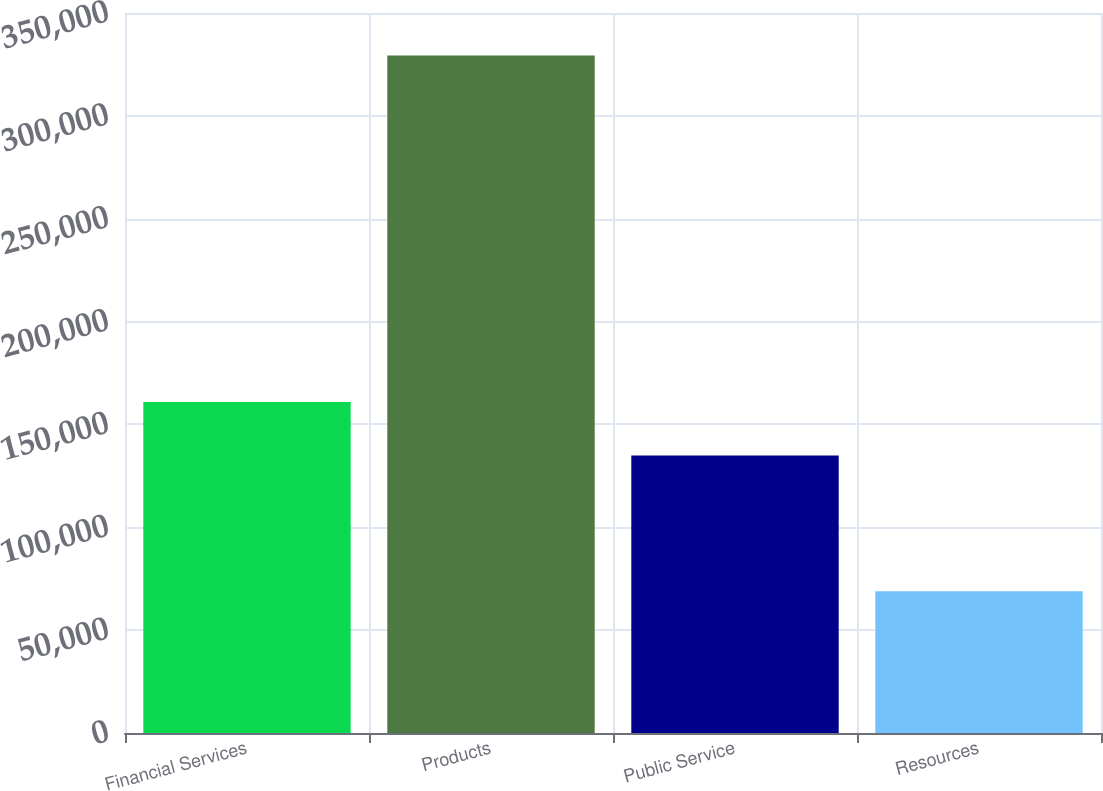Convert chart to OTSL. <chart><loc_0><loc_0><loc_500><loc_500><bar_chart><fcel>Financial Services<fcel>Products<fcel>Public Service<fcel>Resources<nl><fcel>160932<fcel>329332<fcel>134895<fcel>68964<nl></chart> 